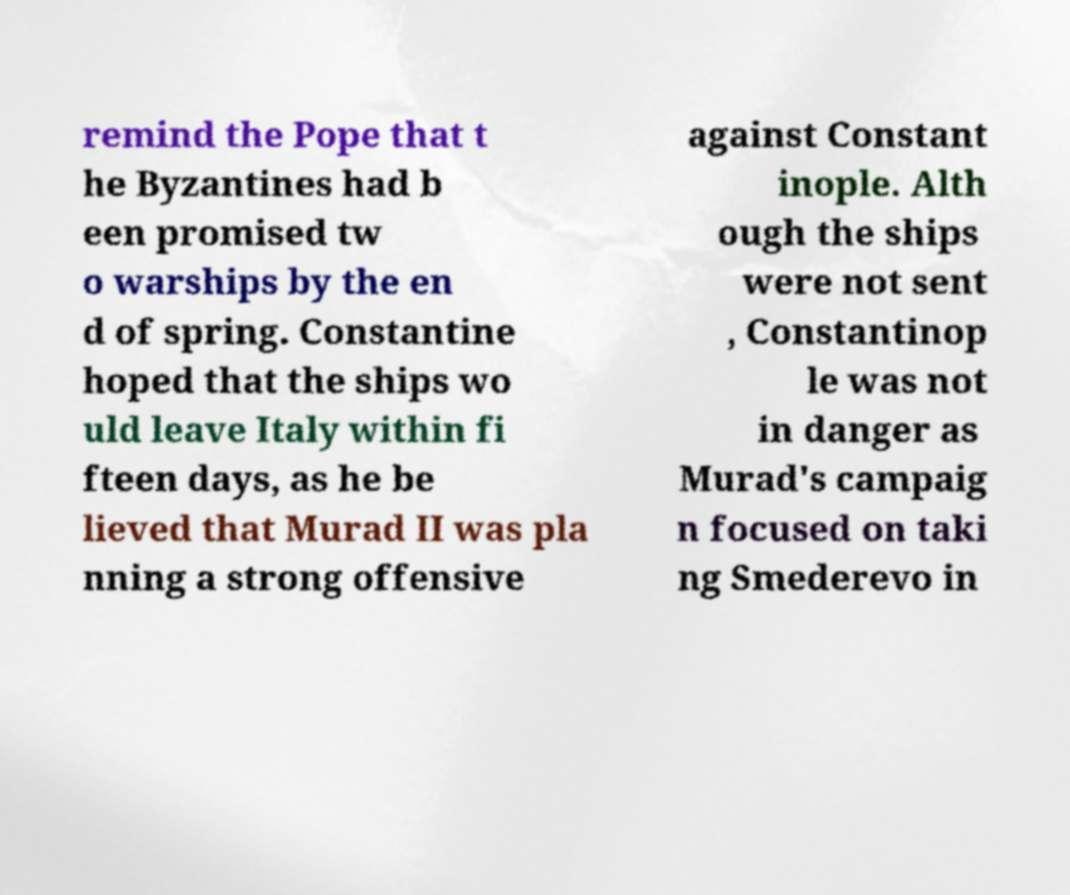Please identify and transcribe the text found in this image. remind the Pope that t he Byzantines had b een promised tw o warships by the en d of spring. Constantine hoped that the ships wo uld leave Italy within fi fteen days, as he be lieved that Murad II was pla nning a strong offensive against Constant inople. Alth ough the ships were not sent , Constantinop le was not in danger as Murad's campaig n focused on taki ng Smederevo in 